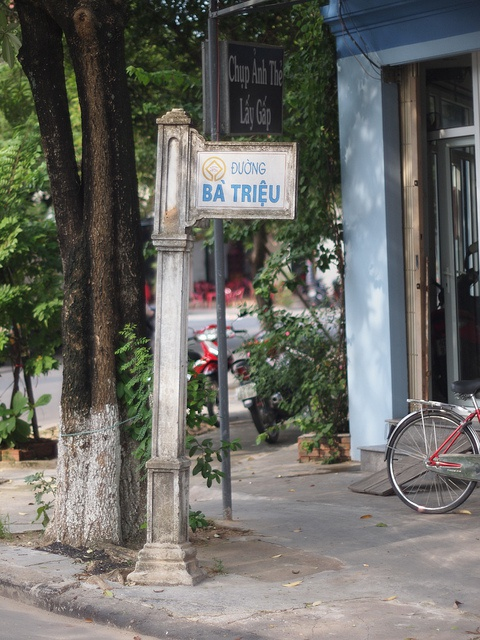Describe the objects in this image and their specific colors. I can see bicycle in black, gray, and darkgray tones and motorcycle in black, gray, lightgray, and darkgray tones in this image. 